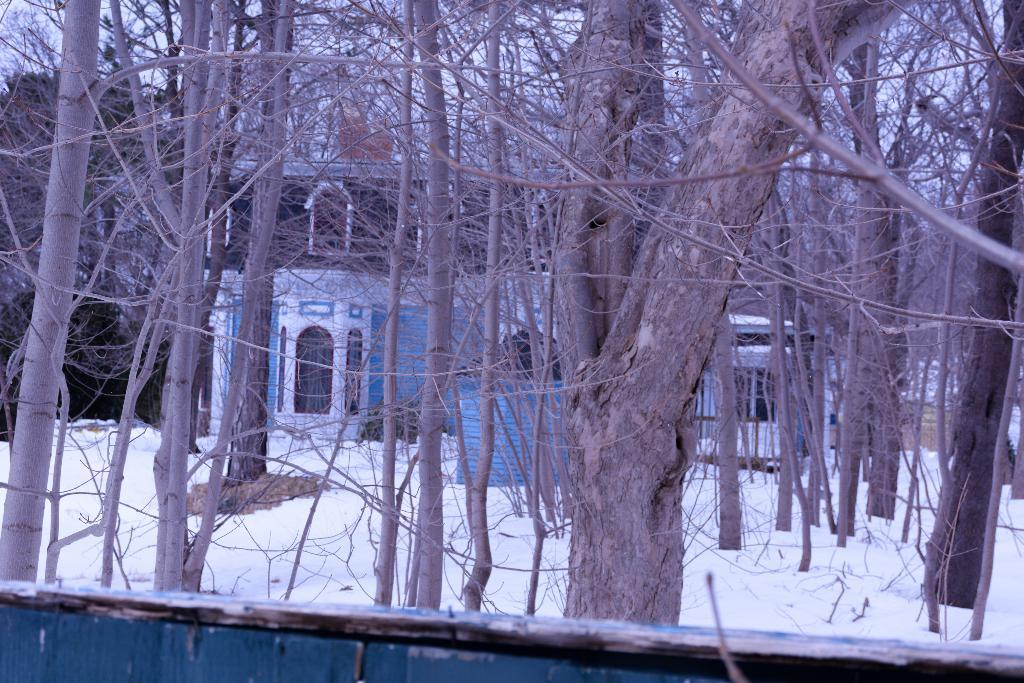What is the condition of the ground in the image? The ground is covered in snow. What type of vegetation can be seen in the image? There are trees in the image. What is visible in the background of the image? There is a building in the background of the image. What part of the natural environment is visible in the image? The sky is visible in the image. What type of bird can be seen sitting on the roof in the image? There is no roof or bird present in the image. What type of yarn is being used to decorate the trees in the image? There is no yarn or decoration present on the trees in the image. 